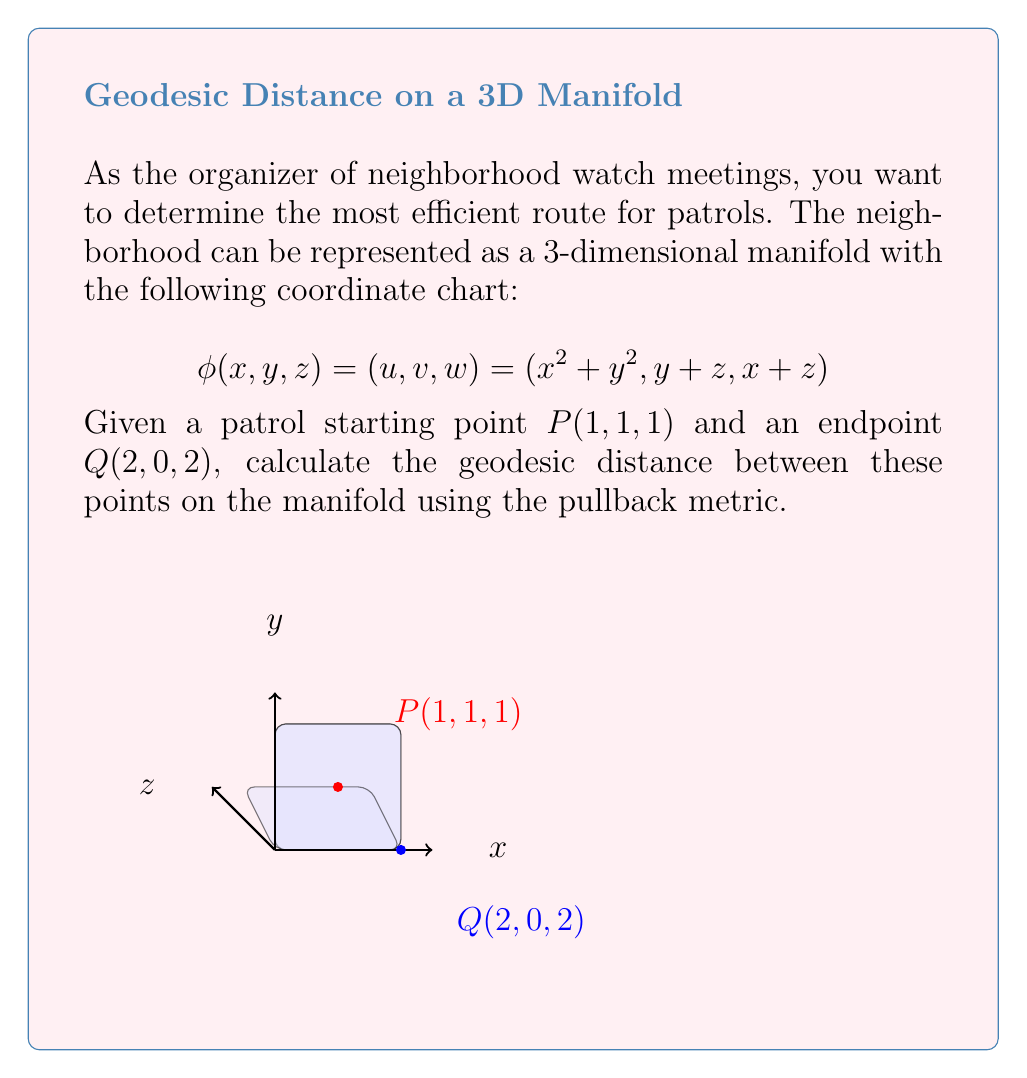Help me with this question. To solve this problem, we'll follow these steps:

1) First, we need to compute the Jacobian matrix of the coordinate transformation:

   $$J = \begin{bmatrix}
   \frac{\partial u}{\partial x} & \frac{\partial u}{\partial y} & \frac{\partial u}{\partial z} \\
   \frac{\partial v}{\partial x} & \frac{\partial v}{\partial y} & \frac{\partial v}{\partial z} \\
   \frac{\partial w}{\partial x} & \frac{\partial w}{\partial y} & \frac{\partial w}{\partial z}
   \end{bmatrix} = \begin{bmatrix}
   2x & 2y & 0 \\
   0 & 1 & 1 \\
   1 & 0 & 1
   \end{bmatrix}$$

2) The pullback metric $g$ is given by $g = J^T J$:

   $$g = \begin{bmatrix}
   4x^2 + 1 & 2xy & 1 \\
   2xy & 4y^2 + 1 & 1 \\
   1 & 1 & 2
   \end{bmatrix}$$

3) To compute the geodesic distance, we need to integrate the arc length:

   $$d = \int_0^1 \sqrt{\dot{\gamma}^T g \dot{\gamma}} dt$$

   where $\gamma(t) = (1+t, 1-t, 1+t)$ is a straight line path from P to Q.

4) We have $\dot{\gamma} = (1, -1, 1)$. Substituting this into the integral:

   $$d = \int_0^1 \sqrt{(1, -1, 1) g (1, -1, 1)^T} dt$$

5) Evaluating $g$ along the path:

   $$g(t) = \begin{bmatrix}
   4(1+t)^2 + 1 & 2(1+t)(1-t) & 1 \\
   2(1+t)(1-t) & 4(1-t)^2 + 1 & 1 \\
   1 & 1 & 2
   \end{bmatrix}$$

6) Computing the integrand:

   $$\dot{\gamma}^T g \dot{\gamma} = 4(1+t)^2 + 1 + 4(1-t)^2 + 1 + 2 - 4(1+t)(1-t) + 2 - 2 = 4t^2 + 8$$

7) Therefore, the geodesic distance is:

   $$d = \int_0^1 \sqrt{4t^2 + 8} dt = \frac{1}{4}[t\sqrt{4t^2+8} + 4\ln(t+\sqrt{t^2+2})]_0^1$$

8) Evaluating the integral:

   $$d = \frac{1}{4}[\sqrt{12} + 4\ln(1+\sqrt{3}) - 4\ln(\sqrt{2})]$$
Answer: $\frac{1}{4}[\sqrt{12} + 4\ln(1+\sqrt{3}) - 4\ln(\sqrt{2})]$ 